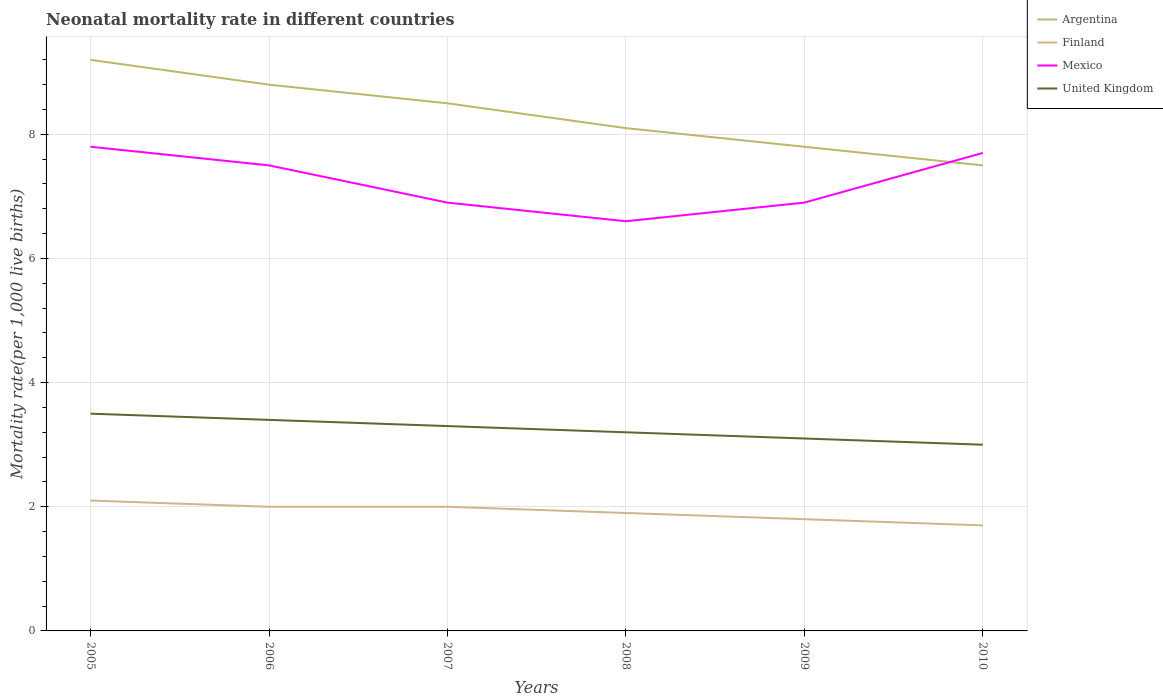Does the line corresponding to Argentina intersect with the line corresponding to Mexico?
Offer a very short reply. Yes. Across all years, what is the maximum neonatal mortality rate in Finland?
Make the answer very short. 1.7. In which year was the neonatal mortality rate in Finland maximum?
Offer a very short reply. 2010. What is the total neonatal mortality rate in United Kingdom in the graph?
Offer a very short reply. 0.4. What is the difference between the highest and the second highest neonatal mortality rate in Argentina?
Ensure brevity in your answer.  1.7. What is the difference between the highest and the lowest neonatal mortality rate in United Kingdom?
Give a very brief answer. 3. How many lines are there?
Your answer should be compact. 4. How many years are there in the graph?
Ensure brevity in your answer.  6. What is the difference between two consecutive major ticks on the Y-axis?
Ensure brevity in your answer.  2. Are the values on the major ticks of Y-axis written in scientific E-notation?
Ensure brevity in your answer.  No. Where does the legend appear in the graph?
Provide a succinct answer. Top right. How many legend labels are there?
Your response must be concise. 4. What is the title of the graph?
Your answer should be compact. Neonatal mortality rate in different countries. What is the label or title of the X-axis?
Offer a terse response. Years. What is the label or title of the Y-axis?
Ensure brevity in your answer.  Mortality rate(per 1,0 live births). What is the Mortality rate(per 1,000 live births) in Mexico in 2005?
Give a very brief answer. 7.8. What is the Mortality rate(per 1,000 live births) of United Kingdom in 2005?
Make the answer very short. 3.5. What is the Mortality rate(per 1,000 live births) of Argentina in 2006?
Your answer should be very brief. 8.8. What is the Mortality rate(per 1,000 live births) of Mexico in 2006?
Keep it short and to the point. 7.5. What is the Mortality rate(per 1,000 live births) of United Kingdom in 2006?
Give a very brief answer. 3.4. What is the Mortality rate(per 1,000 live births) of Finland in 2008?
Keep it short and to the point. 1.9. What is the Mortality rate(per 1,000 live births) of United Kingdom in 2008?
Ensure brevity in your answer.  3.2. What is the Mortality rate(per 1,000 live births) of Argentina in 2009?
Ensure brevity in your answer.  7.8. What is the Mortality rate(per 1,000 live births) of Mexico in 2009?
Offer a terse response. 6.9. What is the Mortality rate(per 1,000 live births) in United Kingdom in 2009?
Give a very brief answer. 3.1. What is the Mortality rate(per 1,000 live births) of Mexico in 2010?
Offer a terse response. 7.7. Across all years, what is the maximum Mortality rate(per 1,000 live births) in Argentina?
Offer a terse response. 9.2. Across all years, what is the maximum Mortality rate(per 1,000 live births) of Finland?
Provide a succinct answer. 2.1. Across all years, what is the minimum Mortality rate(per 1,000 live births) in United Kingdom?
Make the answer very short. 3. What is the total Mortality rate(per 1,000 live births) in Argentina in the graph?
Your answer should be compact. 49.9. What is the total Mortality rate(per 1,000 live births) of Mexico in the graph?
Offer a terse response. 43.4. What is the difference between the Mortality rate(per 1,000 live births) of Finland in 2005 and that in 2006?
Offer a terse response. 0.1. What is the difference between the Mortality rate(per 1,000 live births) of Mexico in 2005 and that in 2006?
Your answer should be compact. 0.3. What is the difference between the Mortality rate(per 1,000 live births) in Argentina in 2005 and that in 2007?
Provide a succinct answer. 0.7. What is the difference between the Mortality rate(per 1,000 live births) of Finland in 2005 and that in 2007?
Provide a succinct answer. 0.1. What is the difference between the Mortality rate(per 1,000 live births) of Mexico in 2005 and that in 2007?
Provide a short and direct response. 0.9. What is the difference between the Mortality rate(per 1,000 live births) in United Kingdom in 2005 and that in 2007?
Provide a short and direct response. 0.2. What is the difference between the Mortality rate(per 1,000 live births) in Finland in 2005 and that in 2008?
Offer a very short reply. 0.2. What is the difference between the Mortality rate(per 1,000 live births) in United Kingdom in 2005 and that in 2008?
Offer a terse response. 0.3. What is the difference between the Mortality rate(per 1,000 live births) of Argentina in 2005 and that in 2009?
Give a very brief answer. 1.4. What is the difference between the Mortality rate(per 1,000 live births) in Argentina in 2005 and that in 2010?
Ensure brevity in your answer.  1.7. What is the difference between the Mortality rate(per 1,000 live births) in Finland in 2005 and that in 2010?
Provide a succinct answer. 0.4. What is the difference between the Mortality rate(per 1,000 live births) in Mexico in 2005 and that in 2010?
Your answer should be very brief. 0.1. What is the difference between the Mortality rate(per 1,000 live births) of Argentina in 2006 and that in 2007?
Make the answer very short. 0.3. What is the difference between the Mortality rate(per 1,000 live births) in Mexico in 2006 and that in 2007?
Keep it short and to the point. 0.6. What is the difference between the Mortality rate(per 1,000 live births) of United Kingdom in 2006 and that in 2007?
Offer a very short reply. 0.1. What is the difference between the Mortality rate(per 1,000 live births) in Finland in 2006 and that in 2008?
Your answer should be compact. 0.1. What is the difference between the Mortality rate(per 1,000 live births) in Mexico in 2006 and that in 2008?
Your answer should be compact. 0.9. What is the difference between the Mortality rate(per 1,000 live births) in United Kingdom in 2006 and that in 2008?
Make the answer very short. 0.2. What is the difference between the Mortality rate(per 1,000 live births) in Argentina in 2006 and that in 2009?
Give a very brief answer. 1. What is the difference between the Mortality rate(per 1,000 live births) in Finland in 2006 and that in 2009?
Your answer should be very brief. 0.2. What is the difference between the Mortality rate(per 1,000 live births) in Mexico in 2006 and that in 2009?
Make the answer very short. 0.6. What is the difference between the Mortality rate(per 1,000 live births) of United Kingdom in 2006 and that in 2009?
Offer a very short reply. 0.3. What is the difference between the Mortality rate(per 1,000 live births) of Mexico in 2006 and that in 2010?
Give a very brief answer. -0.2. What is the difference between the Mortality rate(per 1,000 live births) in United Kingdom in 2007 and that in 2008?
Keep it short and to the point. 0.1. What is the difference between the Mortality rate(per 1,000 live births) of United Kingdom in 2007 and that in 2010?
Ensure brevity in your answer.  0.3. What is the difference between the Mortality rate(per 1,000 live births) in Argentina in 2008 and that in 2009?
Offer a terse response. 0.3. What is the difference between the Mortality rate(per 1,000 live births) of Finland in 2008 and that in 2009?
Your answer should be compact. 0.1. What is the difference between the Mortality rate(per 1,000 live births) in Mexico in 2008 and that in 2009?
Keep it short and to the point. -0.3. What is the difference between the Mortality rate(per 1,000 live births) in Mexico in 2008 and that in 2010?
Offer a terse response. -1.1. What is the difference between the Mortality rate(per 1,000 live births) of Finland in 2009 and that in 2010?
Offer a terse response. 0.1. What is the difference between the Mortality rate(per 1,000 live births) in Argentina in 2005 and the Mortality rate(per 1,000 live births) in Finland in 2006?
Your response must be concise. 7.2. What is the difference between the Mortality rate(per 1,000 live births) of Argentina in 2005 and the Mortality rate(per 1,000 live births) of Mexico in 2006?
Offer a very short reply. 1.7. What is the difference between the Mortality rate(per 1,000 live births) of Argentina in 2005 and the Mortality rate(per 1,000 live births) of Finland in 2007?
Make the answer very short. 7.2. What is the difference between the Mortality rate(per 1,000 live births) of Argentina in 2005 and the Mortality rate(per 1,000 live births) of Mexico in 2007?
Offer a terse response. 2.3. What is the difference between the Mortality rate(per 1,000 live births) of Argentina in 2005 and the Mortality rate(per 1,000 live births) of United Kingdom in 2007?
Keep it short and to the point. 5.9. What is the difference between the Mortality rate(per 1,000 live births) of Mexico in 2005 and the Mortality rate(per 1,000 live births) of United Kingdom in 2007?
Your response must be concise. 4.5. What is the difference between the Mortality rate(per 1,000 live births) of Argentina in 2005 and the Mortality rate(per 1,000 live births) of Finland in 2008?
Make the answer very short. 7.3. What is the difference between the Mortality rate(per 1,000 live births) of Argentina in 2005 and the Mortality rate(per 1,000 live births) of Mexico in 2008?
Ensure brevity in your answer.  2.6. What is the difference between the Mortality rate(per 1,000 live births) of Argentina in 2005 and the Mortality rate(per 1,000 live births) of United Kingdom in 2008?
Keep it short and to the point. 6. What is the difference between the Mortality rate(per 1,000 live births) in Mexico in 2005 and the Mortality rate(per 1,000 live births) in United Kingdom in 2008?
Provide a short and direct response. 4.6. What is the difference between the Mortality rate(per 1,000 live births) in Argentina in 2005 and the Mortality rate(per 1,000 live births) in Finland in 2009?
Offer a terse response. 7.4. What is the difference between the Mortality rate(per 1,000 live births) of Finland in 2005 and the Mortality rate(per 1,000 live births) of Mexico in 2009?
Keep it short and to the point. -4.8. What is the difference between the Mortality rate(per 1,000 live births) of Finland in 2005 and the Mortality rate(per 1,000 live births) of United Kingdom in 2009?
Your response must be concise. -1. What is the difference between the Mortality rate(per 1,000 live births) of Mexico in 2005 and the Mortality rate(per 1,000 live births) of United Kingdom in 2009?
Keep it short and to the point. 4.7. What is the difference between the Mortality rate(per 1,000 live births) in Argentina in 2005 and the Mortality rate(per 1,000 live births) in Finland in 2010?
Ensure brevity in your answer.  7.5. What is the difference between the Mortality rate(per 1,000 live births) of Argentina in 2006 and the Mortality rate(per 1,000 live births) of Finland in 2007?
Provide a short and direct response. 6.8. What is the difference between the Mortality rate(per 1,000 live births) in Argentina in 2006 and the Mortality rate(per 1,000 live births) in Mexico in 2007?
Your answer should be compact. 1.9. What is the difference between the Mortality rate(per 1,000 live births) in Finland in 2006 and the Mortality rate(per 1,000 live births) in United Kingdom in 2007?
Give a very brief answer. -1.3. What is the difference between the Mortality rate(per 1,000 live births) in Argentina in 2006 and the Mortality rate(per 1,000 live births) in United Kingdom in 2008?
Offer a terse response. 5.6. What is the difference between the Mortality rate(per 1,000 live births) in Finland in 2006 and the Mortality rate(per 1,000 live births) in Mexico in 2008?
Offer a very short reply. -4.6. What is the difference between the Mortality rate(per 1,000 live births) in Mexico in 2006 and the Mortality rate(per 1,000 live births) in United Kingdom in 2008?
Provide a short and direct response. 4.3. What is the difference between the Mortality rate(per 1,000 live births) in Argentina in 2006 and the Mortality rate(per 1,000 live births) in Finland in 2009?
Your answer should be very brief. 7. What is the difference between the Mortality rate(per 1,000 live births) in Argentina in 2006 and the Mortality rate(per 1,000 live births) in Mexico in 2009?
Provide a short and direct response. 1.9. What is the difference between the Mortality rate(per 1,000 live births) of Argentina in 2006 and the Mortality rate(per 1,000 live births) of United Kingdom in 2009?
Give a very brief answer. 5.7. What is the difference between the Mortality rate(per 1,000 live births) of Finland in 2006 and the Mortality rate(per 1,000 live births) of United Kingdom in 2009?
Make the answer very short. -1.1. What is the difference between the Mortality rate(per 1,000 live births) in Argentina in 2006 and the Mortality rate(per 1,000 live births) in Finland in 2010?
Your response must be concise. 7.1. What is the difference between the Mortality rate(per 1,000 live births) in Argentina in 2006 and the Mortality rate(per 1,000 live births) in Mexico in 2010?
Provide a succinct answer. 1.1. What is the difference between the Mortality rate(per 1,000 live births) in Argentina in 2006 and the Mortality rate(per 1,000 live births) in United Kingdom in 2010?
Keep it short and to the point. 5.8. What is the difference between the Mortality rate(per 1,000 live births) of Finland in 2006 and the Mortality rate(per 1,000 live births) of Mexico in 2010?
Keep it short and to the point. -5.7. What is the difference between the Mortality rate(per 1,000 live births) of Mexico in 2006 and the Mortality rate(per 1,000 live births) of United Kingdom in 2010?
Give a very brief answer. 4.5. What is the difference between the Mortality rate(per 1,000 live births) of Argentina in 2007 and the Mortality rate(per 1,000 live births) of United Kingdom in 2008?
Your response must be concise. 5.3. What is the difference between the Mortality rate(per 1,000 live births) of Finland in 2007 and the Mortality rate(per 1,000 live births) of Mexico in 2008?
Your answer should be very brief. -4.6. What is the difference between the Mortality rate(per 1,000 live births) in Argentina in 2007 and the Mortality rate(per 1,000 live births) in Finland in 2009?
Your response must be concise. 6.7. What is the difference between the Mortality rate(per 1,000 live births) in Argentina in 2007 and the Mortality rate(per 1,000 live births) in Mexico in 2009?
Make the answer very short. 1.6. What is the difference between the Mortality rate(per 1,000 live births) in Argentina in 2007 and the Mortality rate(per 1,000 live births) in United Kingdom in 2009?
Your response must be concise. 5.4. What is the difference between the Mortality rate(per 1,000 live births) in Finland in 2007 and the Mortality rate(per 1,000 live births) in Mexico in 2009?
Provide a succinct answer. -4.9. What is the difference between the Mortality rate(per 1,000 live births) in Finland in 2007 and the Mortality rate(per 1,000 live births) in United Kingdom in 2009?
Provide a short and direct response. -1.1. What is the difference between the Mortality rate(per 1,000 live births) in Argentina in 2007 and the Mortality rate(per 1,000 live births) in Finland in 2010?
Your answer should be compact. 6.8. What is the difference between the Mortality rate(per 1,000 live births) of Argentina in 2007 and the Mortality rate(per 1,000 live births) of Mexico in 2010?
Offer a terse response. 0.8. What is the difference between the Mortality rate(per 1,000 live births) of Finland in 2007 and the Mortality rate(per 1,000 live births) of Mexico in 2010?
Provide a succinct answer. -5.7. What is the difference between the Mortality rate(per 1,000 live births) in Argentina in 2008 and the Mortality rate(per 1,000 live births) in Finland in 2009?
Your answer should be very brief. 6.3. What is the difference between the Mortality rate(per 1,000 live births) in Argentina in 2008 and the Mortality rate(per 1,000 live births) in United Kingdom in 2009?
Make the answer very short. 5. What is the difference between the Mortality rate(per 1,000 live births) of Finland in 2008 and the Mortality rate(per 1,000 live births) of Mexico in 2009?
Ensure brevity in your answer.  -5. What is the difference between the Mortality rate(per 1,000 live births) in Finland in 2008 and the Mortality rate(per 1,000 live births) in Mexico in 2010?
Offer a terse response. -5.8. What is the difference between the Mortality rate(per 1,000 live births) in Mexico in 2008 and the Mortality rate(per 1,000 live births) in United Kingdom in 2010?
Your response must be concise. 3.6. What is the difference between the Mortality rate(per 1,000 live births) in Argentina in 2009 and the Mortality rate(per 1,000 live births) in Finland in 2010?
Provide a short and direct response. 6.1. What is the difference between the Mortality rate(per 1,000 live births) of Argentina in 2009 and the Mortality rate(per 1,000 live births) of Mexico in 2010?
Your response must be concise. 0.1. What is the difference between the Mortality rate(per 1,000 live births) of Finland in 2009 and the Mortality rate(per 1,000 live births) of United Kingdom in 2010?
Provide a succinct answer. -1.2. What is the difference between the Mortality rate(per 1,000 live births) of Mexico in 2009 and the Mortality rate(per 1,000 live births) of United Kingdom in 2010?
Your answer should be compact. 3.9. What is the average Mortality rate(per 1,000 live births) of Argentina per year?
Provide a short and direct response. 8.32. What is the average Mortality rate(per 1,000 live births) of Finland per year?
Provide a succinct answer. 1.92. What is the average Mortality rate(per 1,000 live births) in Mexico per year?
Provide a short and direct response. 7.23. What is the average Mortality rate(per 1,000 live births) in United Kingdom per year?
Keep it short and to the point. 3.25. In the year 2005, what is the difference between the Mortality rate(per 1,000 live births) of Argentina and Mortality rate(per 1,000 live births) of Finland?
Give a very brief answer. 7.1. In the year 2005, what is the difference between the Mortality rate(per 1,000 live births) in Argentina and Mortality rate(per 1,000 live births) in United Kingdom?
Provide a short and direct response. 5.7. In the year 2006, what is the difference between the Mortality rate(per 1,000 live births) of Argentina and Mortality rate(per 1,000 live births) of United Kingdom?
Your response must be concise. 5.4. In the year 2006, what is the difference between the Mortality rate(per 1,000 live births) in Mexico and Mortality rate(per 1,000 live births) in United Kingdom?
Give a very brief answer. 4.1. In the year 2007, what is the difference between the Mortality rate(per 1,000 live births) in Argentina and Mortality rate(per 1,000 live births) in Mexico?
Give a very brief answer. 1.6. In the year 2007, what is the difference between the Mortality rate(per 1,000 live births) of Argentina and Mortality rate(per 1,000 live births) of United Kingdom?
Give a very brief answer. 5.2. In the year 2007, what is the difference between the Mortality rate(per 1,000 live births) of Mexico and Mortality rate(per 1,000 live births) of United Kingdom?
Ensure brevity in your answer.  3.6. In the year 2008, what is the difference between the Mortality rate(per 1,000 live births) in Argentina and Mortality rate(per 1,000 live births) in Mexico?
Give a very brief answer. 1.5. In the year 2008, what is the difference between the Mortality rate(per 1,000 live births) of Argentina and Mortality rate(per 1,000 live births) of United Kingdom?
Provide a short and direct response. 4.9. In the year 2008, what is the difference between the Mortality rate(per 1,000 live births) in Finland and Mortality rate(per 1,000 live births) in United Kingdom?
Make the answer very short. -1.3. In the year 2009, what is the difference between the Mortality rate(per 1,000 live births) in Finland and Mortality rate(per 1,000 live births) in Mexico?
Provide a succinct answer. -5.1. In the year 2009, what is the difference between the Mortality rate(per 1,000 live births) in Finland and Mortality rate(per 1,000 live births) in United Kingdom?
Provide a short and direct response. -1.3. In the year 2010, what is the difference between the Mortality rate(per 1,000 live births) in Argentina and Mortality rate(per 1,000 live births) in Finland?
Provide a short and direct response. 5.8. In the year 2010, what is the difference between the Mortality rate(per 1,000 live births) of Finland and Mortality rate(per 1,000 live births) of Mexico?
Make the answer very short. -6. What is the ratio of the Mortality rate(per 1,000 live births) of Argentina in 2005 to that in 2006?
Make the answer very short. 1.05. What is the ratio of the Mortality rate(per 1,000 live births) of Finland in 2005 to that in 2006?
Give a very brief answer. 1.05. What is the ratio of the Mortality rate(per 1,000 live births) of Mexico in 2005 to that in 2006?
Your answer should be very brief. 1.04. What is the ratio of the Mortality rate(per 1,000 live births) of United Kingdom in 2005 to that in 2006?
Ensure brevity in your answer.  1.03. What is the ratio of the Mortality rate(per 1,000 live births) in Argentina in 2005 to that in 2007?
Your response must be concise. 1.08. What is the ratio of the Mortality rate(per 1,000 live births) in Finland in 2005 to that in 2007?
Provide a short and direct response. 1.05. What is the ratio of the Mortality rate(per 1,000 live births) of Mexico in 2005 to that in 2007?
Keep it short and to the point. 1.13. What is the ratio of the Mortality rate(per 1,000 live births) of United Kingdom in 2005 to that in 2007?
Make the answer very short. 1.06. What is the ratio of the Mortality rate(per 1,000 live births) in Argentina in 2005 to that in 2008?
Your response must be concise. 1.14. What is the ratio of the Mortality rate(per 1,000 live births) of Finland in 2005 to that in 2008?
Ensure brevity in your answer.  1.11. What is the ratio of the Mortality rate(per 1,000 live births) in Mexico in 2005 to that in 2008?
Provide a short and direct response. 1.18. What is the ratio of the Mortality rate(per 1,000 live births) in United Kingdom in 2005 to that in 2008?
Provide a short and direct response. 1.09. What is the ratio of the Mortality rate(per 1,000 live births) of Argentina in 2005 to that in 2009?
Ensure brevity in your answer.  1.18. What is the ratio of the Mortality rate(per 1,000 live births) of Mexico in 2005 to that in 2009?
Offer a very short reply. 1.13. What is the ratio of the Mortality rate(per 1,000 live births) in United Kingdom in 2005 to that in 2009?
Offer a terse response. 1.13. What is the ratio of the Mortality rate(per 1,000 live births) of Argentina in 2005 to that in 2010?
Ensure brevity in your answer.  1.23. What is the ratio of the Mortality rate(per 1,000 live births) in Finland in 2005 to that in 2010?
Your answer should be very brief. 1.24. What is the ratio of the Mortality rate(per 1,000 live births) of Mexico in 2005 to that in 2010?
Your answer should be compact. 1.01. What is the ratio of the Mortality rate(per 1,000 live births) in United Kingdom in 2005 to that in 2010?
Your response must be concise. 1.17. What is the ratio of the Mortality rate(per 1,000 live births) of Argentina in 2006 to that in 2007?
Provide a succinct answer. 1.04. What is the ratio of the Mortality rate(per 1,000 live births) in Finland in 2006 to that in 2007?
Keep it short and to the point. 1. What is the ratio of the Mortality rate(per 1,000 live births) of Mexico in 2006 to that in 2007?
Make the answer very short. 1.09. What is the ratio of the Mortality rate(per 1,000 live births) in United Kingdom in 2006 to that in 2007?
Ensure brevity in your answer.  1.03. What is the ratio of the Mortality rate(per 1,000 live births) in Argentina in 2006 to that in 2008?
Your answer should be compact. 1.09. What is the ratio of the Mortality rate(per 1,000 live births) of Finland in 2006 to that in 2008?
Give a very brief answer. 1.05. What is the ratio of the Mortality rate(per 1,000 live births) of Mexico in 2006 to that in 2008?
Your answer should be compact. 1.14. What is the ratio of the Mortality rate(per 1,000 live births) of Argentina in 2006 to that in 2009?
Your answer should be compact. 1.13. What is the ratio of the Mortality rate(per 1,000 live births) in Finland in 2006 to that in 2009?
Ensure brevity in your answer.  1.11. What is the ratio of the Mortality rate(per 1,000 live births) in Mexico in 2006 to that in 2009?
Ensure brevity in your answer.  1.09. What is the ratio of the Mortality rate(per 1,000 live births) of United Kingdom in 2006 to that in 2009?
Offer a terse response. 1.1. What is the ratio of the Mortality rate(per 1,000 live births) in Argentina in 2006 to that in 2010?
Provide a short and direct response. 1.17. What is the ratio of the Mortality rate(per 1,000 live births) in Finland in 2006 to that in 2010?
Your answer should be compact. 1.18. What is the ratio of the Mortality rate(per 1,000 live births) in Mexico in 2006 to that in 2010?
Provide a short and direct response. 0.97. What is the ratio of the Mortality rate(per 1,000 live births) in United Kingdom in 2006 to that in 2010?
Offer a very short reply. 1.13. What is the ratio of the Mortality rate(per 1,000 live births) of Argentina in 2007 to that in 2008?
Offer a terse response. 1.05. What is the ratio of the Mortality rate(per 1,000 live births) in Finland in 2007 to that in 2008?
Offer a very short reply. 1.05. What is the ratio of the Mortality rate(per 1,000 live births) of Mexico in 2007 to that in 2008?
Provide a short and direct response. 1.05. What is the ratio of the Mortality rate(per 1,000 live births) of United Kingdom in 2007 to that in 2008?
Provide a succinct answer. 1.03. What is the ratio of the Mortality rate(per 1,000 live births) of Argentina in 2007 to that in 2009?
Your answer should be compact. 1.09. What is the ratio of the Mortality rate(per 1,000 live births) of Finland in 2007 to that in 2009?
Give a very brief answer. 1.11. What is the ratio of the Mortality rate(per 1,000 live births) of United Kingdom in 2007 to that in 2009?
Your answer should be compact. 1.06. What is the ratio of the Mortality rate(per 1,000 live births) of Argentina in 2007 to that in 2010?
Provide a succinct answer. 1.13. What is the ratio of the Mortality rate(per 1,000 live births) in Finland in 2007 to that in 2010?
Keep it short and to the point. 1.18. What is the ratio of the Mortality rate(per 1,000 live births) of Mexico in 2007 to that in 2010?
Offer a terse response. 0.9. What is the ratio of the Mortality rate(per 1,000 live births) in Finland in 2008 to that in 2009?
Offer a terse response. 1.06. What is the ratio of the Mortality rate(per 1,000 live births) in Mexico in 2008 to that in 2009?
Ensure brevity in your answer.  0.96. What is the ratio of the Mortality rate(per 1,000 live births) of United Kingdom in 2008 to that in 2009?
Ensure brevity in your answer.  1.03. What is the ratio of the Mortality rate(per 1,000 live births) in Argentina in 2008 to that in 2010?
Make the answer very short. 1.08. What is the ratio of the Mortality rate(per 1,000 live births) of Finland in 2008 to that in 2010?
Offer a very short reply. 1.12. What is the ratio of the Mortality rate(per 1,000 live births) of Mexico in 2008 to that in 2010?
Make the answer very short. 0.86. What is the ratio of the Mortality rate(per 1,000 live births) in United Kingdom in 2008 to that in 2010?
Provide a succinct answer. 1.07. What is the ratio of the Mortality rate(per 1,000 live births) in Argentina in 2009 to that in 2010?
Your answer should be compact. 1.04. What is the ratio of the Mortality rate(per 1,000 live births) of Finland in 2009 to that in 2010?
Offer a terse response. 1.06. What is the ratio of the Mortality rate(per 1,000 live births) of Mexico in 2009 to that in 2010?
Offer a very short reply. 0.9. What is the difference between the highest and the second highest Mortality rate(per 1,000 live births) in Finland?
Your response must be concise. 0.1. What is the difference between the highest and the second highest Mortality rate(per 1,000 live births) in United Kingdom?
Give a very brief answer. 0.1. What is the difference between the highest and the lowest Mortality rate(per 1,000 live births) in Argentina?
Your answer should be compact. 1.7. What is the difference between the highest and the lowest Mortality rate(per 1,000 live births) in Finland?
Offer a very short reply. 0.4. What is the difference between the highest and the lowest Mortality rate(per 1,000 live births) of Mexico?
Ensure brevity in your answer.  1.2. What is the difference between the highest and the lowest Mortality rate(per 1,000 live births) in United Kingdom?
Provide a succinct answer. 0.5. 